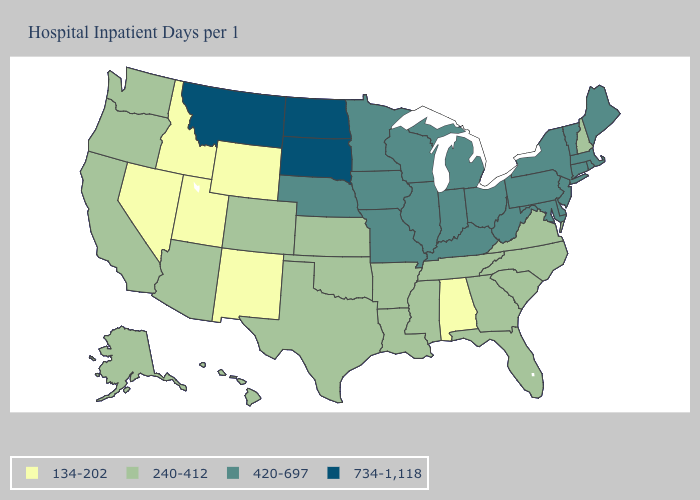What is the value of Tennessee?
Give a very brief answer. 240-412. Does Kansas have the lowest value in the MidWest?
Concise answer only. Yes. What is the value of California?
Short answer required. 240-412. Among the states that border Washington , which have the lowest value?
Write a very short answer. Idaho. Among the states that border Washington , does Oregon have the lowest value?
Write a very short answer. No. Name the states that have a value in the range 420-697?
Give a very brief answer. Connecticut, Delaware, Illinois, Indiana, Iowa, Kentucky, Maine, Maryland, Massachusetts, Michigan, Minnesota, Missouri, Nebraska, New Jersey, New York, Ohio, Pennsylvania, Rhode Island, Vermont, West Virginia, Wisconsin. Does the first symbol in the legend represent the smallest category?
Give a very brief answer. Yes. Does Oklahoma have a lower value than Minnesota?
Give a very brief answer. Yes. What is the value of Montana?
Quick response, please. 734-1,118. What is the value of Maryland?
Be succinct. 420-697. Which states have the lowest value in the South?
Quick response, please. Alabama. Does New Hampshire have the lowest value in the Northeast?
Be succinct. Yes. What is the highest value in states that border South Carolina?
Keep it brief. 240-412. What is the highest value in states that border West Virginia?
Concise answer only. 420-697. Name the states that have a value in the range 420-697?
Quick response, please. Connecticut, Delaware, Illinois, Indiana, Iowa, Kentucky, Maine, Maryland, Massachusetts, Michigan, Minnesota, Missouri, Nebraska, New Jersey, New York, Ohio, Pennsylvania, Rhode Island, Vermont, West Virginia, Wisconsin. 